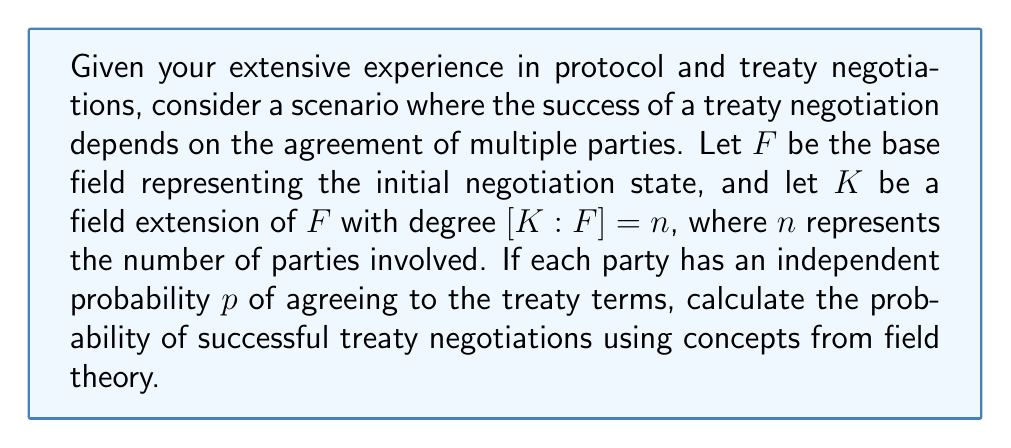Show me your answer to this math problem. To solve this problem, we'll use concepts from field theory and probability theory:

1) In field theory, the degree of the field extension $[K:F] = n$ represents the number of parties involved in the negotiation.

2) Each party has an independent probability $p$ of agreeing to the treaty terms.

3) For the treaty to be successful, all parties must agree. This is analogous to the concept of a splitting field in field theory, where all roots of a polynomial must be present.

4) The probability of all parties agreeing is the product of their individual probabilities, as the events are independent.

5) Therefore, the probability of successful treaty negotiations is:

   $$P(\text{success}) = p^n$$

   Where $n = [K:F]$ is the degree of the field extension.

6) This formula combines the field theory concept of extension degree with the probability concept of independent events.

For example, if there are 5 parties ($n = 5$) and each has a 0.8 probability of agreeing ($p = 0.8$), the probability of successful negotiations would be:

$$P(\text{success}) = 0.8^5 = 0.32768$$

This approach allows you to quantify the likelihood of success based on the number of parties involved and their individual probabilities of agreement, using the framework of field extensions.
Answer: $p^{[K:F]}$ 